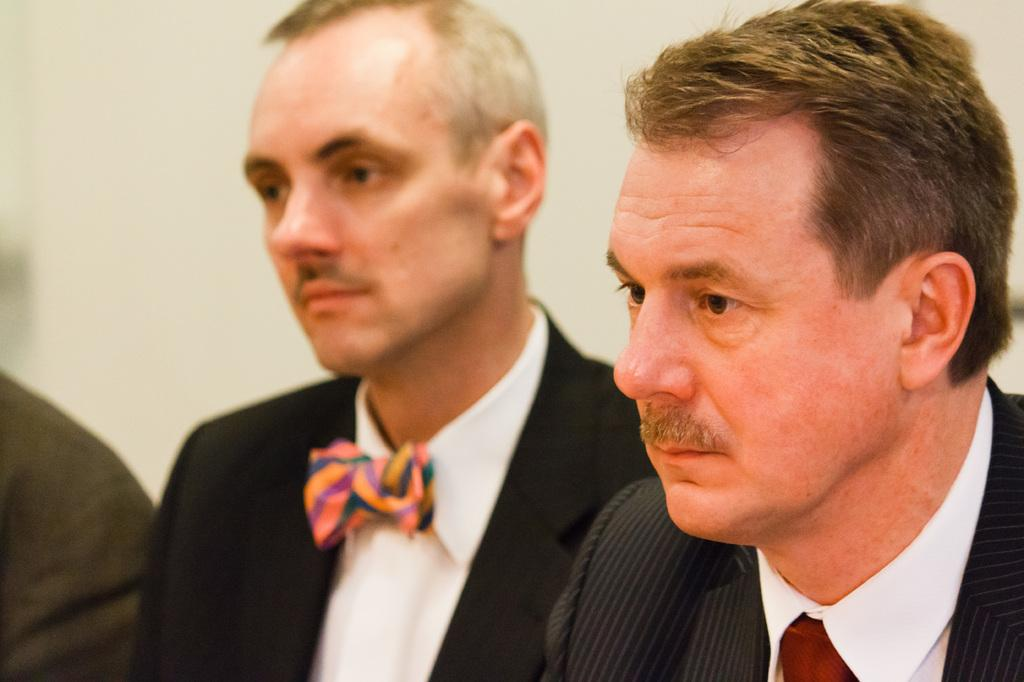How many people are in the foreground of the image? There are two persons in the foreground of the image. What are the two persons in the foreground doing? The two persons in the foreground are sitting. Can you describe the position of the third person in the image? There is another person on the left side of the image, also sitting. What can be seen in the background of the image? There is a wall in the background of the image. What type of kitten can be seen playing with bells in the image? There is no kitten or bells present in the image. Can you describe the spot where the kitten is playing with bells in the image? There is no kitten or bells present in the image, so there is no spot to describe. 